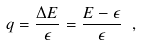Convert formula to latex. <formula><loc_0><loc_0><loc_500><loc_500>q = \frac { \Delta E } { \epsilon } = \frac { E - \epsilon } { \epsilon } \ , \</formula> 